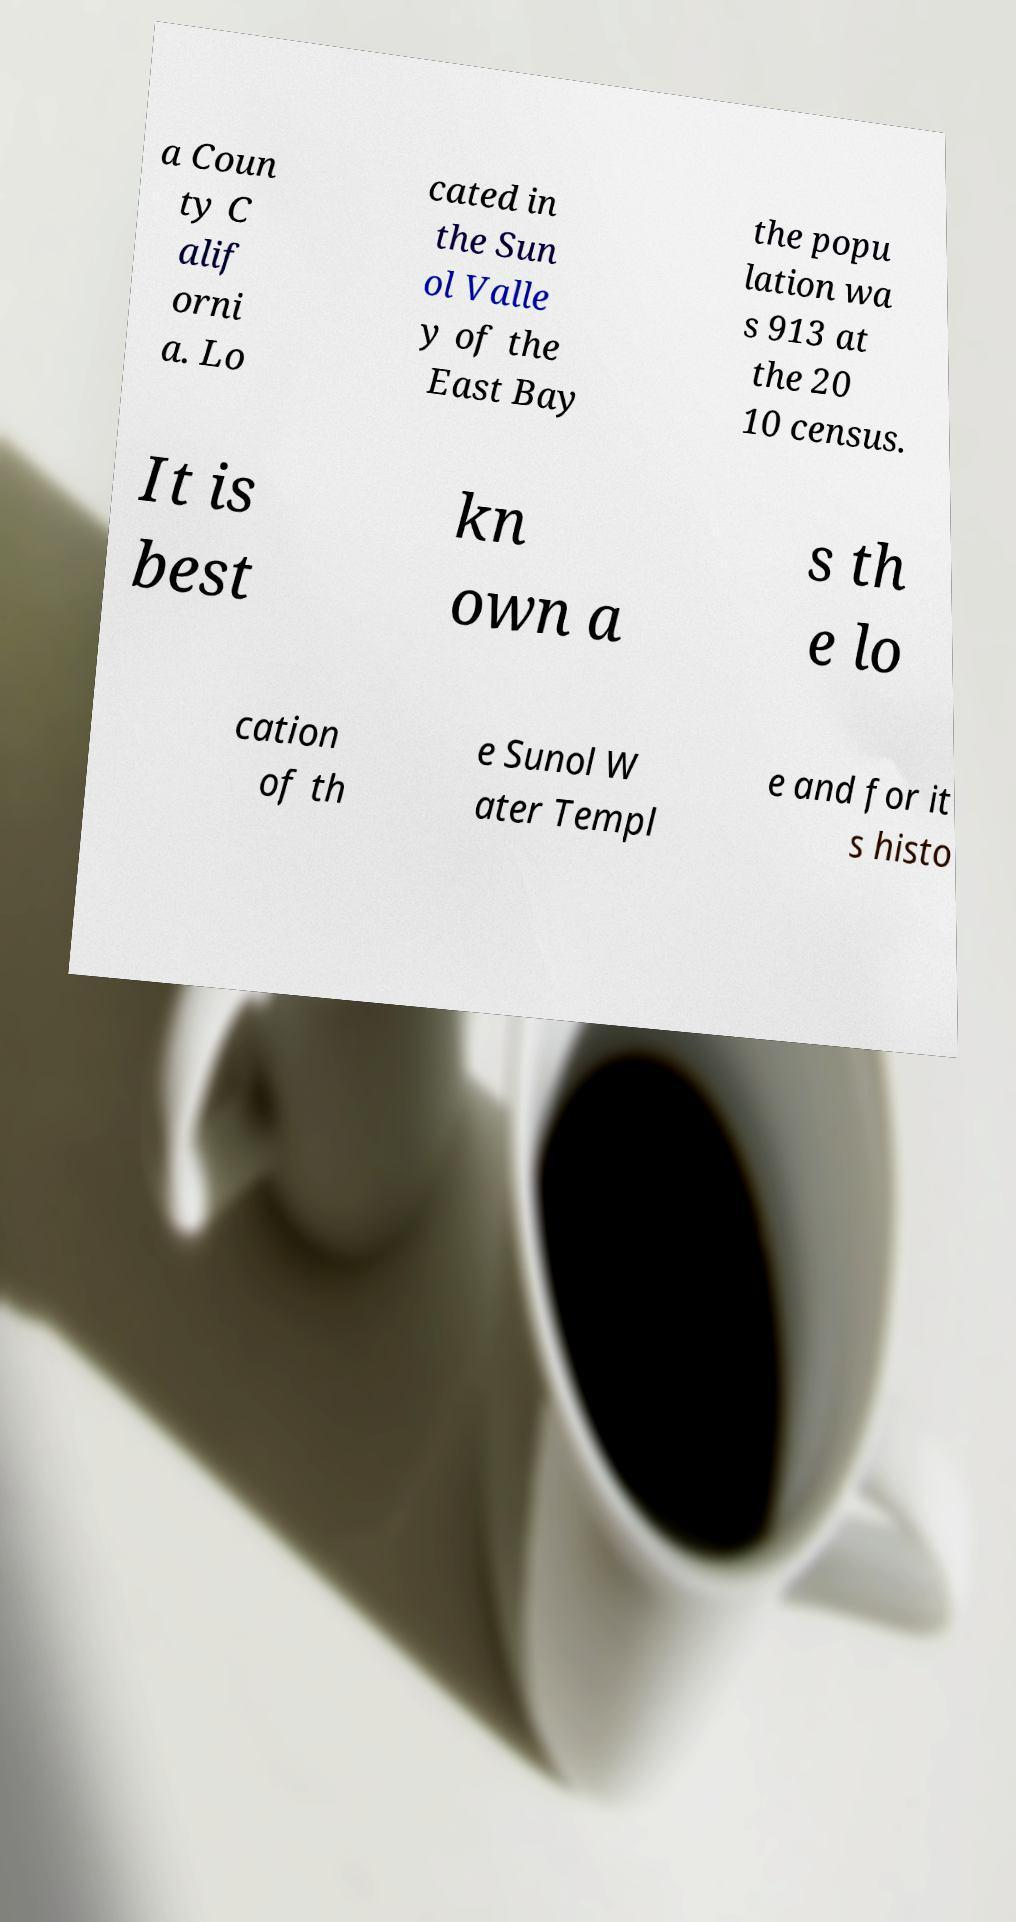There's text embedded in this image that I need extracted. Can you transcribe it verbatim? a Coun ty C alif orni a. Lo cated in the Sun ol Valle y of the East Bay the popu lation wa s 913 at the 20 10 census. It is best kn own a s th e lo cation of th e Sunol W ater Templ e and for it s histo 